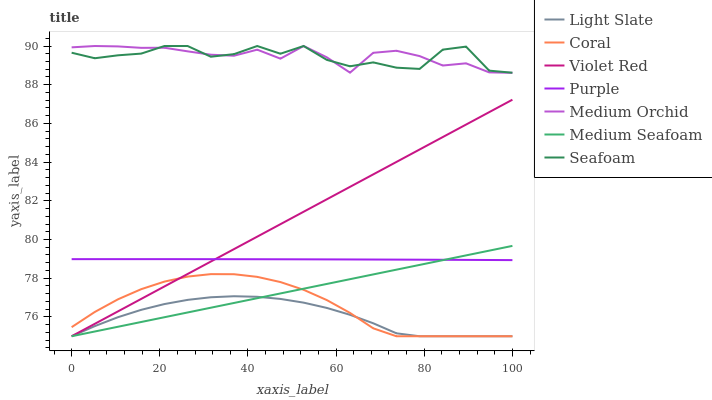Does Light Slate have the minimum area under the curve?
Answer yes or no. Yes. Does Medium Orchid have the maximum area under the curve?
Answer yes or no. Yes. Does Coral have the minimum area under the curve?
Answer yes or no. No. Does Coral have the maximum area under the curve?
Answer yes or no. No. Is Medium Seafoam the smoothest?
Answer yes or no. Yes. Is Seafoam the roughest?
Answer yes or no. Yes. Is Light Slate the smoothest?
Answer yes or no. No. Is Light Slate the roughest?
Answer yes or no. No. Does Violet Red have the lowest value?
Answer yes or no. Yes. Does Medium Orchid have the lowest value?
Answer yes or no. No. Does Seafoam have the highest value?
Answer yes or no. Yes. Does Coral have the highest value?
Answer yes or no. No. Is Light Slate less than Seafoam?
Answer yes or no. Yes. Is Medium Orchid greater than Violet Red?
Answer yes or no. Yes. Does Light Slate intersect Coral?
Answer yes or no. Yes. Is Light Slate less than Coral?
Answer yes or no. No. Is Light Slate greater than Coral?
Answer yes or no. No. Does Light Slate intersect Seafoam?
Answer yes or no. No. 